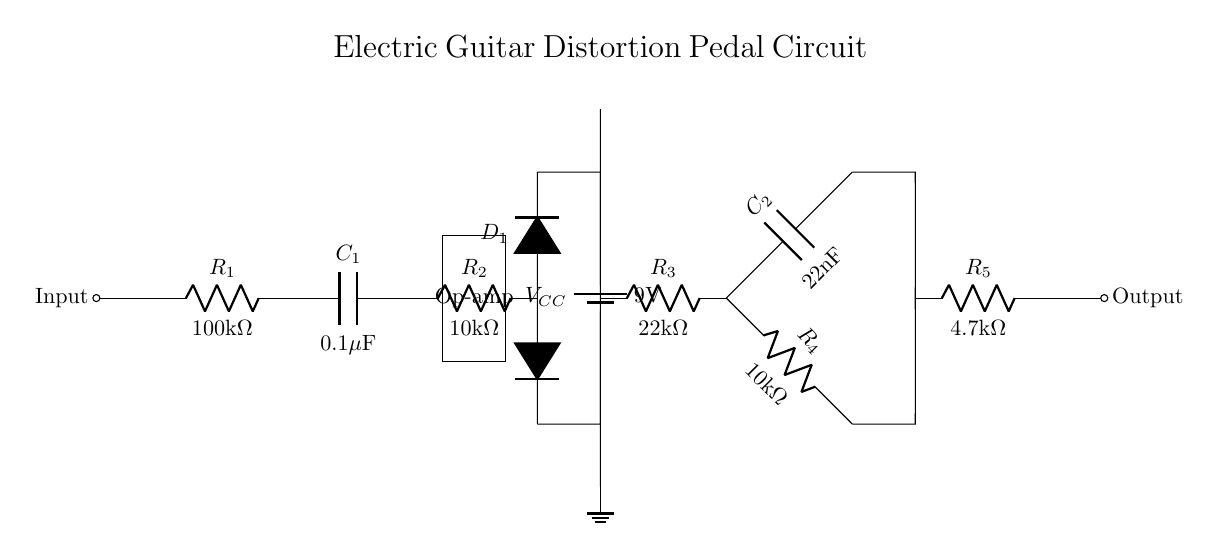What is the value of resistor R1? Resistor R1 is labeled as 100kΩ, which can be read directly from the circuit diagram.
Answer: 100kΩ What component is used for clipping in the circuit? The circuit uses two diodes labeled as D1, which are responsible for clipping the signal. They are positioned at the clipping stage to limit the voltage.
Answer: D1 What is the purpose of capacitor C2 in this circuit? Capacitor C2, which is labeled as 22nF, functions as a tone control element, allowing higher frequencies to pass while blocking lower frequencies, thus shaping the tone of the distorted sound.
Answer: Tone control What is the total resistance from the input to the ground? To find the total resistance, we consider the resistors in series: R1 (100kΩ) + R2 (10kΩ), R3 (22kΩ), and R5 (4.7kΩ), which sum to 146.7kΩ.
Answer: 146.7kΩ How many power supply terminals are in the circuit? The circuit shows one power supply terminal, labeled as VCC, which provides the necessary voltage for the operation of the circuit elements.
Answer: One Which stage in the circuit is responsible for distortion? The clipping stage, which includes R2 and the diodes D1, is where the signal is distorted. This stage actively limits the amplitude of the input signal to create a distorted sound.
Answer: Clipping stage What is the voltage of the power supply used in the circuit? The circuit diagram specifies that the power supply labeled as VCC has a voltage of 9V, which is a standard value used in many effects pedals.
Answer: 9V 